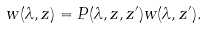Convert formula to latex. <formula><loc_0><loc_0><loc_500><loc_500>w ( \lambda , z ) = P ( \lambda , z , z ^ { \prime } ) w ( \lambda , z ^ { \prime } ) .</formula> 